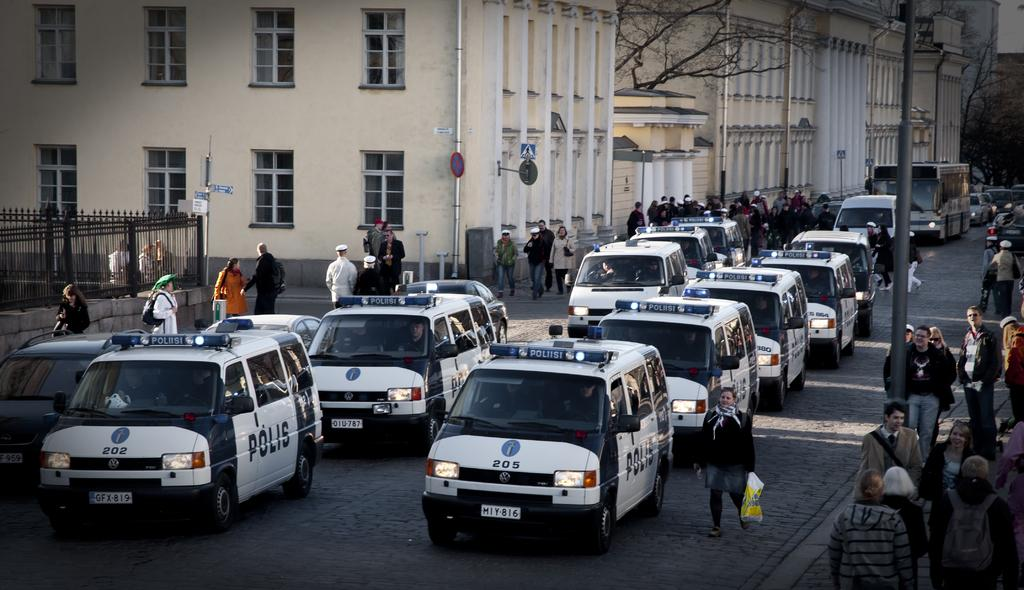<image>
Create a compact narrative representing the image presented. A street full of Polis vehicles, the closest on on the left is number 202. 